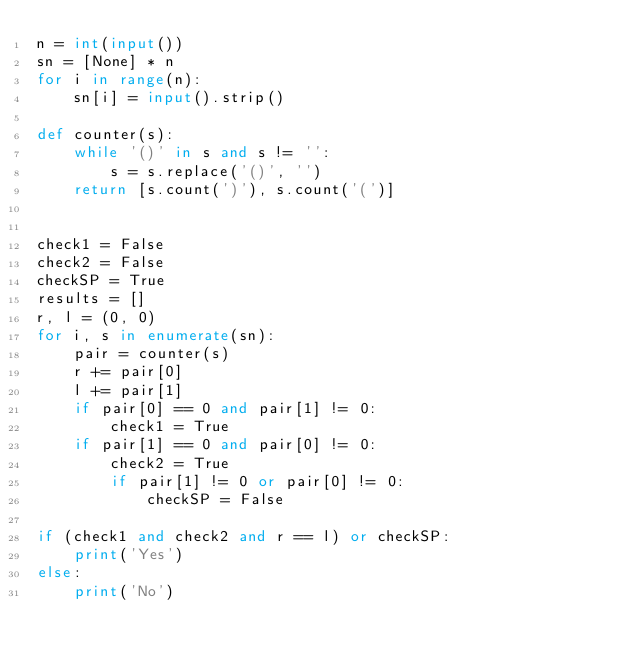Convert code to text. <code><loc_0><loc_0><loc_500><loc_500><_Python_>n = int(input())
sn = [None] * n
for i in range(n):
    sn[i] = input().strip()

def counter(s):
    while '()' in s and s != '':
        s = s.replace('()', '')
    return [s.count(')'), s.count('(')]


check1 = False
check2 = False
checkSP = True
results = []
r, l = (0, 0)
for i, s in enumerate(sn):
    pair = counter(s)
    r += pair[0]
    l += pair[1]
    if pair[0] == 0 and pair[1] != 0:
        check1 = True
    if pair[1] == 0 and pair[0] != 0:
        check2 = True
        if pair[1] != 0 or pair[0] != 0:
            checkSP = False
    
if (check1 and check2 and r == l) or checkSP:
    print('Yes')
else:
    print('No')



</code> 